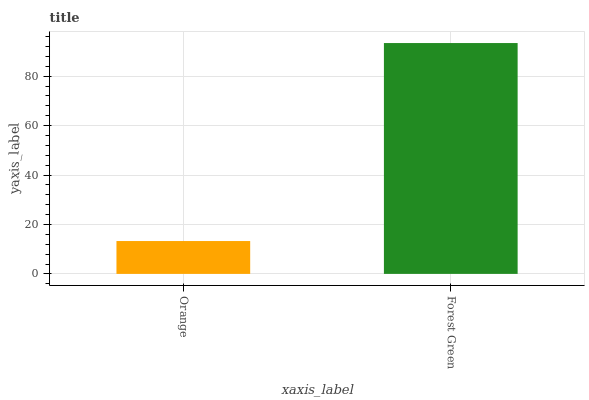Is Orange the minimum?
Answer yes or no. Yes. Is Forest Green the maximum?
Answer yes or no. Yes. Is Forest Green the minimum?
Answer yes or no. No. Is Forest Green greater than Orange?
Answer yes or no. Yes. Is Orange less than Forest Green?
Answer yes or no. Yes. Is Orange greater than Forest Green?
Answer yes or no. No. Is Forest Green less than Orange?
Answer yes or no. No. Is Forest Green the high median?
Answer yes or no. Yes. Is Orange the low median?
Answer yes or no. Yes. Is Orange the high median?
Answer yes or no. No. Is Forest Green the low median?
Answer yes or no. No. 